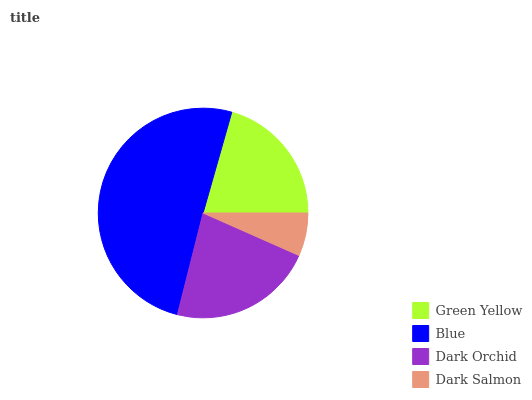Is Dark Salmon the minimum?
Answer yes or no. Yes. Is Blue the maximum?
Answer yes or no. Yes. Is Dark Orchid the minimum?
Answer yes or no. No. Is Dark Orchid the maximum?
Answer yes or no. No. Is Blue greater than Dark Orchid?
Answer yes or no. Yes. Is Dark Orchid less than Blue?
Answer yes or no. Yes. Is Dark Orchid greater than Blue?
Answer yes or no. No. Is Blue less than Dark Orchid?
Answer yes or no. No. Is Dark Orchid the high median?
Answer yes or no. Yes. Is Green Yellow the low median?
Answer yes or no. Yes. Is Green Yellow the high median?
Answer yes or no. No. Is Dark Salmon the low median?
Answer yes or no. No. 